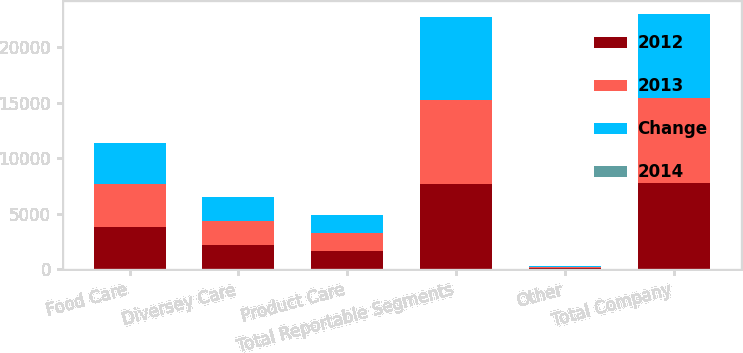Convert chart. <chart><loc_0><loc_0><loc_500><loc_500><stacked_bar_chart><ecel><fcel>Food Care<fcel>Diversey Care<fcel>Product Care<fcel>Total Reportable Segments<fcel>Other<fcel>Total Company<nl><fcel>2012<fcel>3835.3<fcel>2173.1<fcel>1655<fcel>7663.4<fcel>87.1<fcel>7750.5<nl><fcel>2013<fcel>3814.2<fcel>2160.8<fcel>1610<fcel>7585<fcel>105.8<fcel>7690.8<nl><fcel>Change<fcel>3744<fcel>2131.9<fcel>1580.4<fcel>7456.3<fcel>102.9<fcel>7559.2<nl><fcel>2014<fcel>0.6<fcel>0.6<fcel>2.8<fcel>1<fcel>17.7<fcel>0.8<nl></chart> 